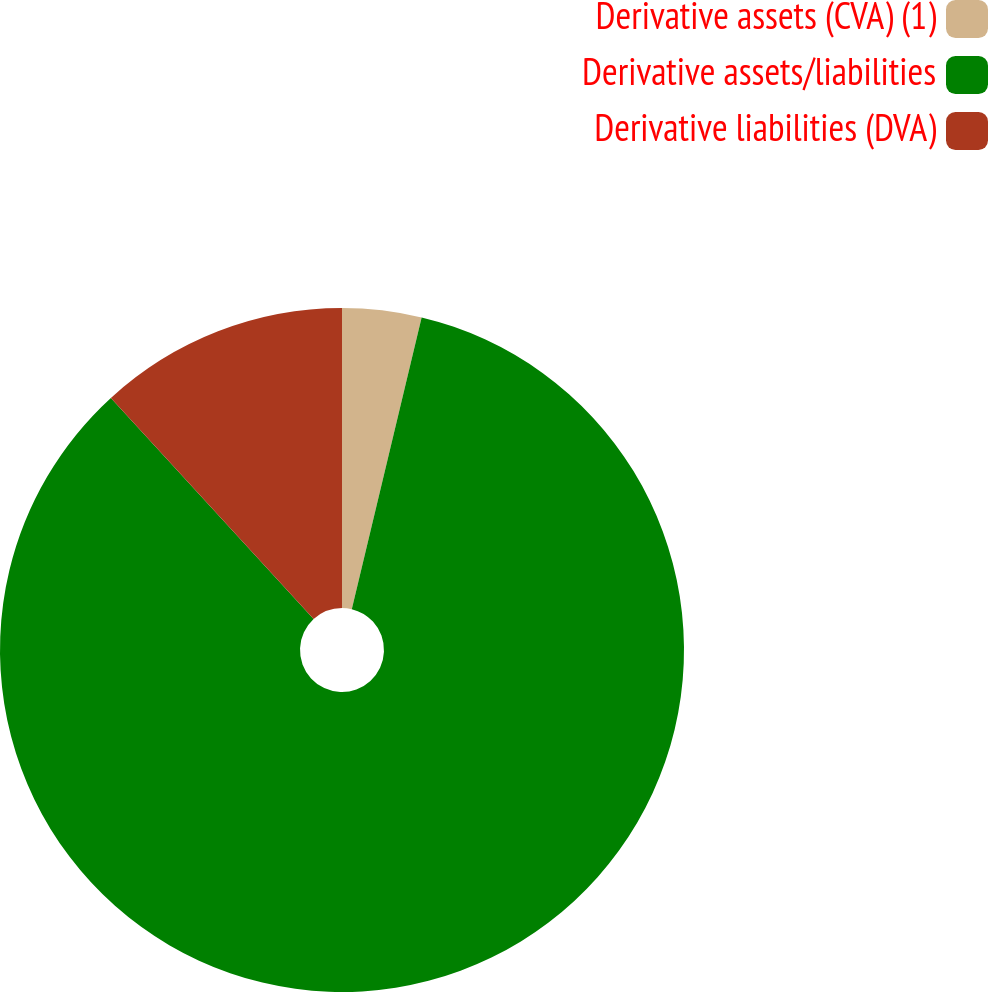<chart> <loc_0><loc_0><loc_500><loc_500><pie_chart><fcel>Derivative assets (CVA) (1)<fcel>Derivative assets/liabilities<fcel>Derivative liabilities (DVA)<nl><fcel>3.74%<fcel>84.45%<fcel>11.81%<nl></chart> 